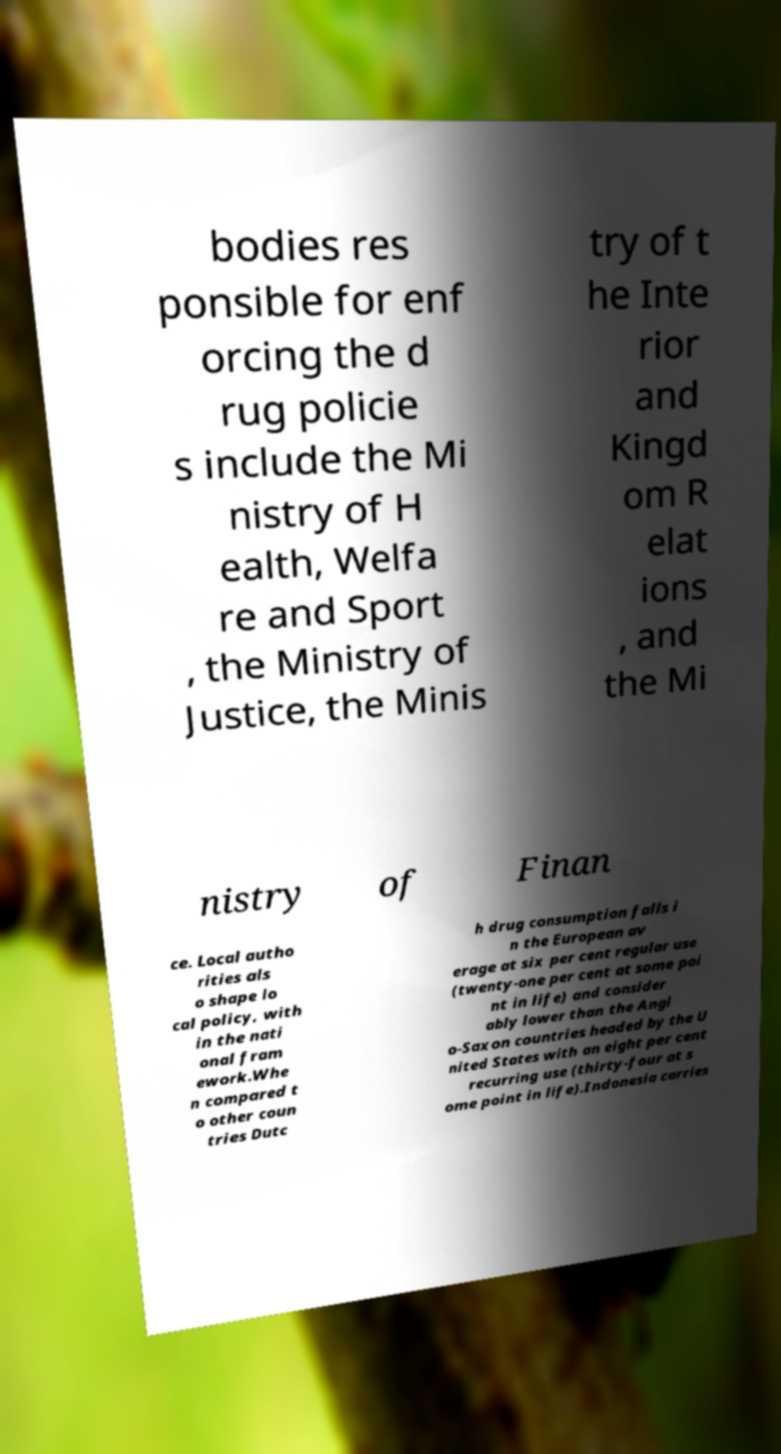I need the written content from this picture converted into text. Can you do that? bodies res ponsible for enf orcing the d rug policie s include the Mi nistry of H ealth, Welfa re and Sport , the Ministry of Justice, the Minis try of t he Inte rior and Kingd om R elat ions , and the Mi nistry of Finan ce. Local autho rities als o shape lo cal policy, with in the nati onal fram ework.Whe n compared t o other coun tries Dutc h drug consumption falls i n the European av erage at six per cent regular use (twenty-one per cent at some poi nt in life) and consider ably lower than the Angl o-Saxon countries headed by the U nited States with an eight per cent recurring use (thirty-four at s ome point in life).Indonesia carries 